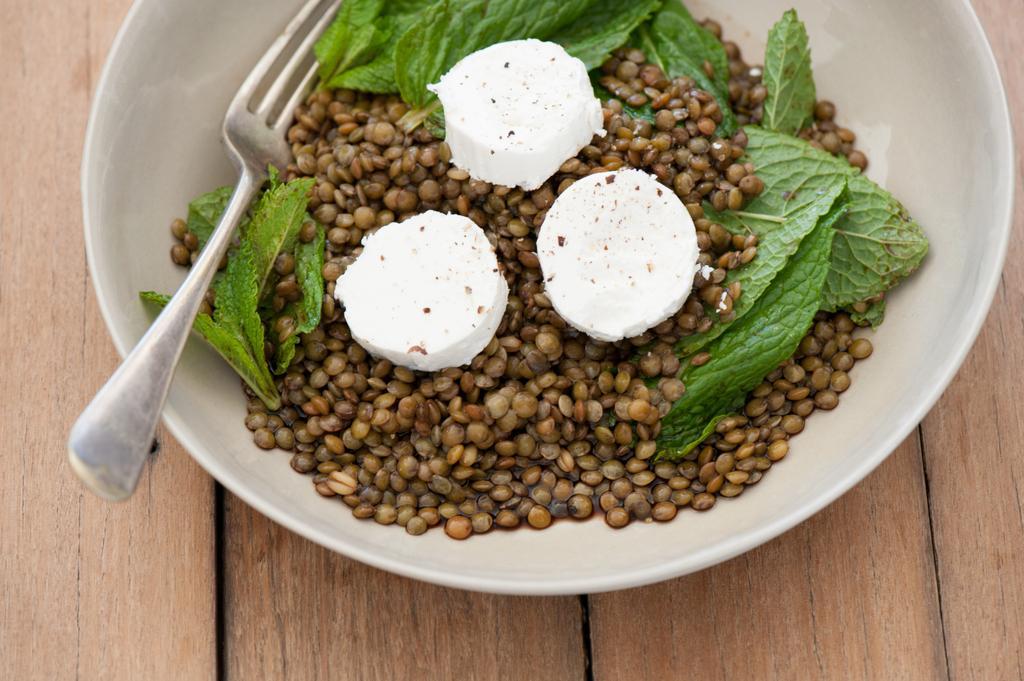How would you summarize this image in a sentence or two? As we can see in the image there is a table. On table there is a bowl. In bowl there is a fork and beans seeds. 